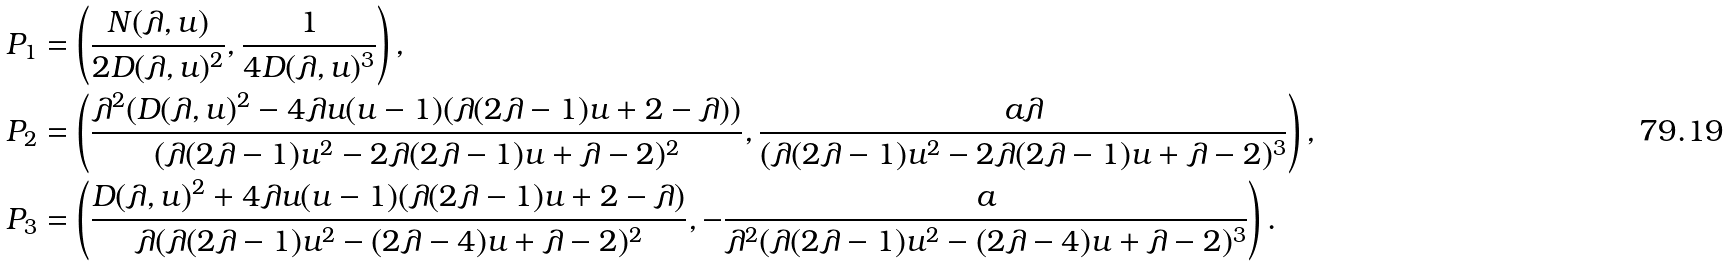Convert formula to latex. <formula><loc_0><loc_0><loc_500><loc_500>P _ { 1 } & = \left ( \frac { N ( \lambda , u ) } { 2 D ( \lambda , u ) ^ { 2 } } , \frac { 1 } { 4 D ( \lambda , u ) ^ { 3 } } \right ) , \\ P _ { 2 } & = \left ( \frac { \lambda ^ { 2 } ( D ( \lambda , u ) ^ { 2 } - 4 \lambda u ( u - 1 ) ( \lambda ( 2 \lambda - 1 ) u + 2 - \lambda ) ) } { ( \lambda ( 2 \lambda - 1 ) u ^ { 2 } - 2 \lambda ( 2 \lambda - 1 ) u + \lambda - 2 ) ^ { 2 } } , \frac { a \lambda } { ( \lambda ( 2 \lambda - 1 ) u ^ { 2 } - 2 \lambda ( 2 \lambda - 1 ) u + \lambda - 2 ) ^ { 3 } } \right ) , \\ P _ { 3 } & = \left ( \frac { D ( \lambda , u ) ^ { 2 } + 4 \lambda u ( u - 1 ) ( \lambda ( 2 \lambda - 1 ) u + 2 - \lambda ) } { \lambda ( \lambda ( 2 \lambda - 1 ) u ^ { 2 } - ( 2 \lambda - 4 ) u + \lambda - 2 ) ^ { 2 } } , - \frac { a } { \lambda ^ { 2 } ( \lambda ( 2 \lambda - 1 ) u ^ { 2 } - ( 2 \lambda - 4 ) u + \lambda - 2 ) ^ { 3 } } \right ) .</formula> 